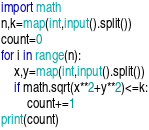Convert code to text. <code><loc_0><loc_0><loc_500><loc_500><_Python_>import math
n,k=map(int,input().split())
count=0
for i in range(n):
    x,y=map(int,input().split())
    if math.sqrt(x**2+y**2)<=k:
        count+=1
print(count)</code> 